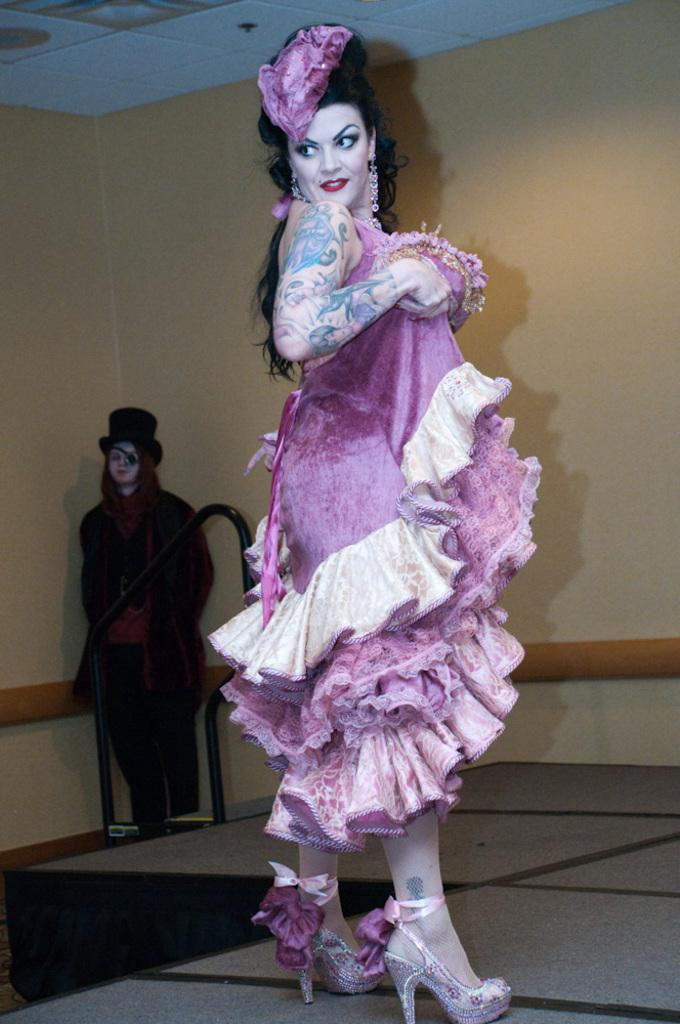What is the main subject of the image? There is a girl standing in the image. What is the girl doing in the image? The girl is holding her clothes. Can you describe the other person visible in the image? There is another person visible in the background of the image, but no specific details are provided. What type of metal is the girl using to read a fiction book in the image? There is no metal or fiction book present in the image; the girl is holding her clothes. 